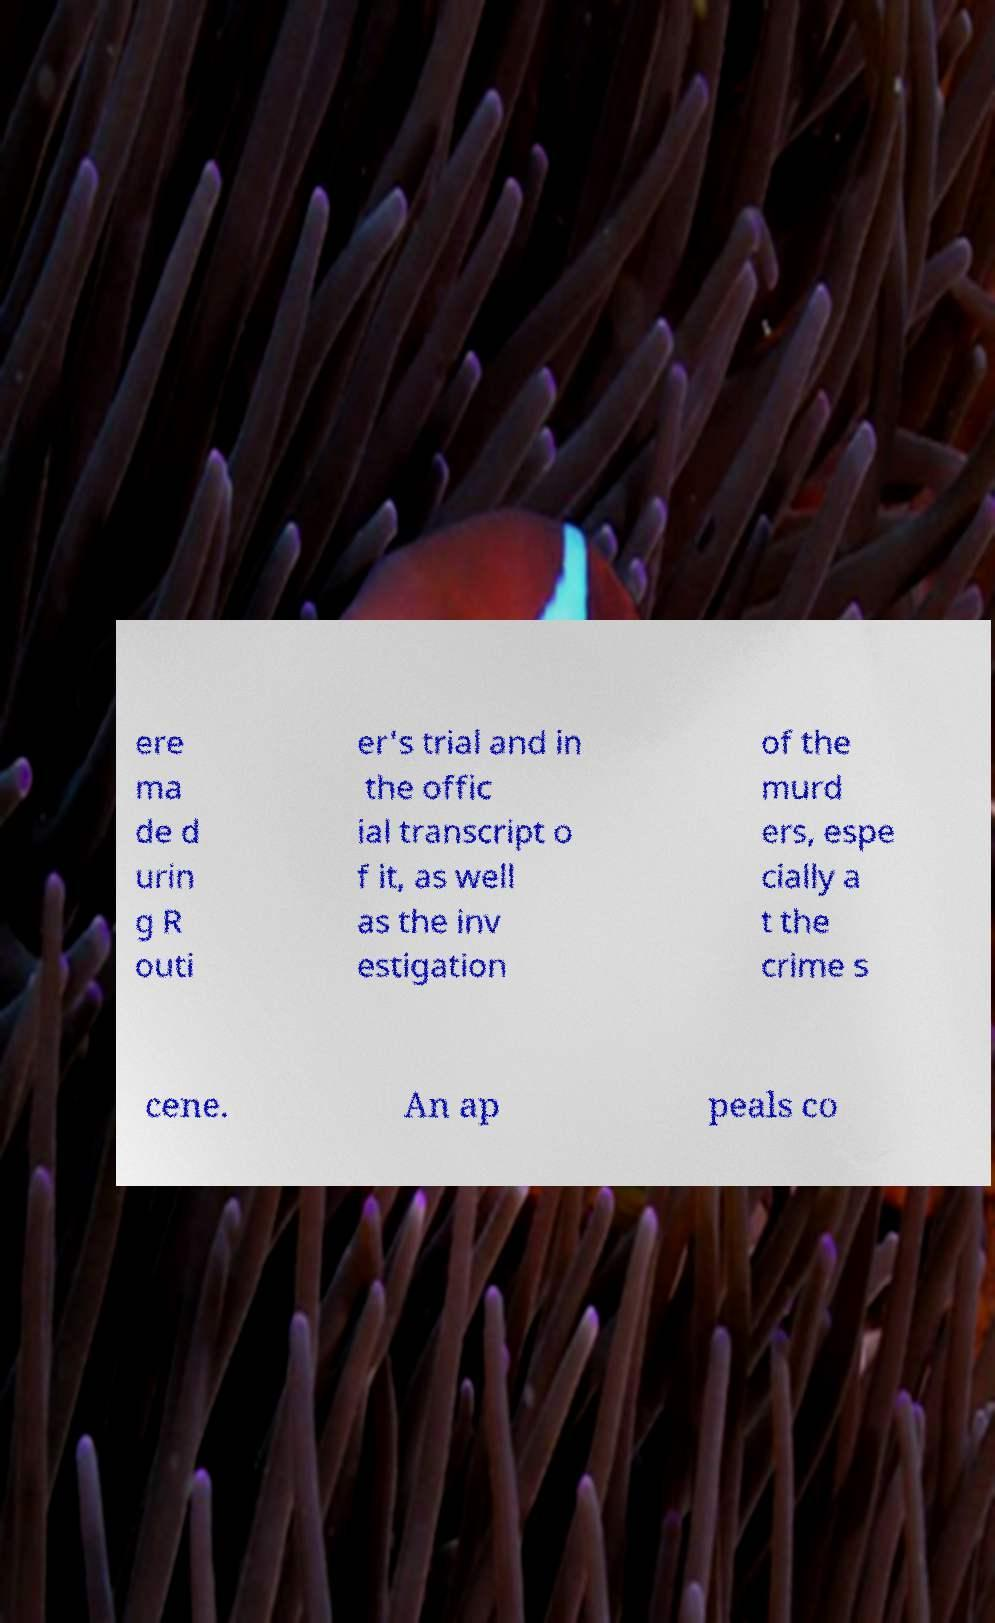For documentation purposes, I need the text within this image transcribed. Could you provide that? ere ma de d urin g R outi er's trial and in the offic ial transcript o f it, as well as the inv estigation of the murd ers, espe cially a t the crime s cene. An ap peals co 